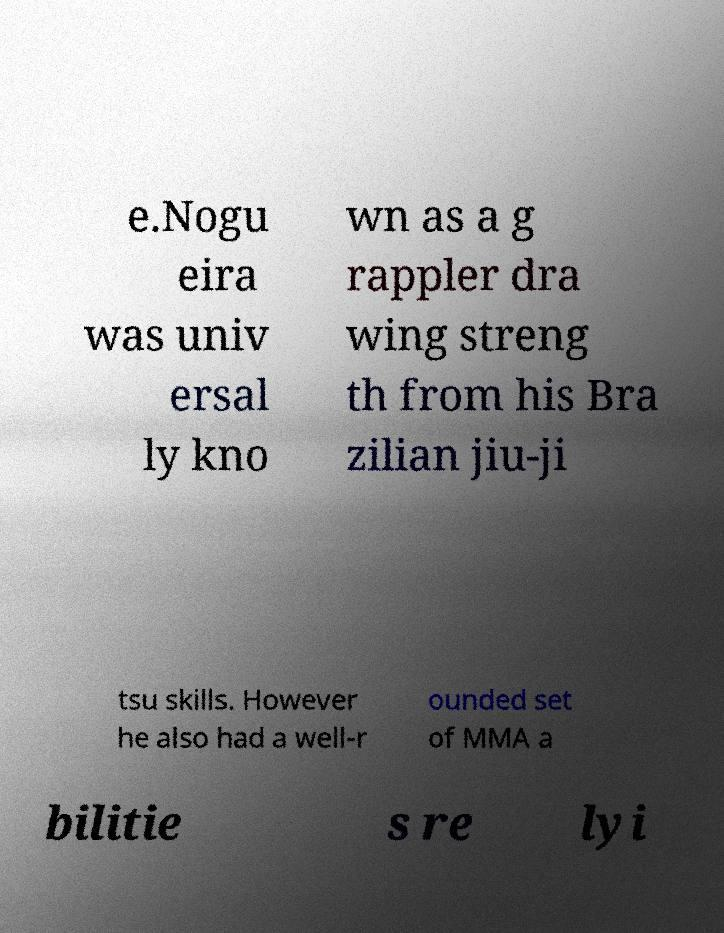There's text embedded in this image that I need extracted. Can you transcribe it verbatim? e.Nogu eira was univ ersal ly kno wn as a g rappler dra wing streng th from his Bra zilian jiu-ji tsu skills. However he also had a well-r ounded set of MMA a bilitie s re lyi 